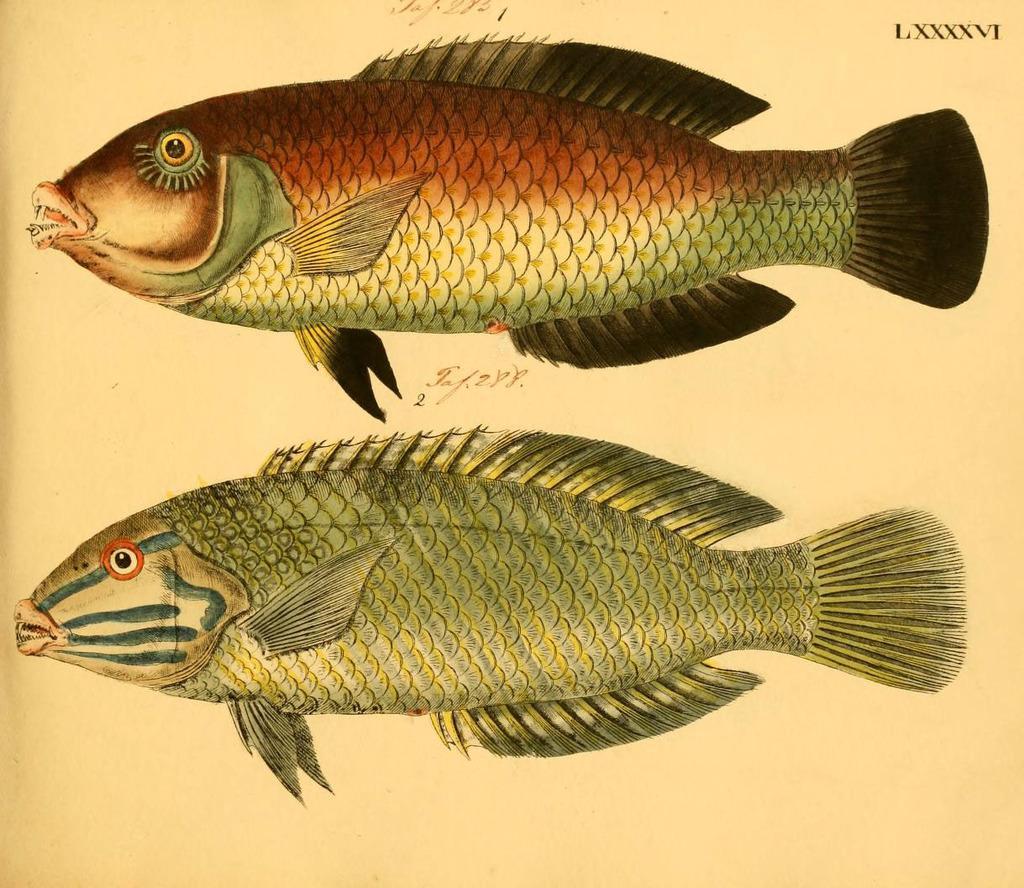Describe this image in one or two sentences. In this image we can see there is a sketch of two fishes. 